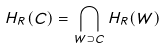<formula> <loc_0><loc_0><loc_500><loc_500>H _ { R } ( C ) = \bigcap _ { W \supset C } H _ { R } ( W )</formula> 